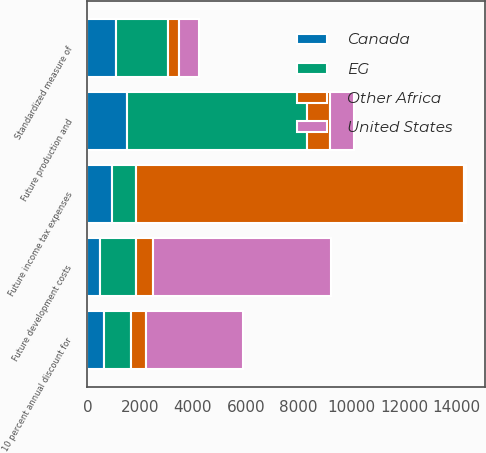Convert chart to OTSL. <chart><loc_0><loc_0><loc_500><loc_500><stacked_bar_chart><ecel><fcel>Future production and<fcel>Future development costs<fcel>Future income tax expenses<fcel>10 percent annual discount for<fcel>Standardized measure of<nl><fcel>EG<fcel>6796<fcel>1362<fcel>923<fcel>1041<fcel>1972<nl><fcel>United States<fcel>935<fcel>6715<fcel>60<fcel>3658<fcel>730<nl><fcel>Canada<fcel>1514<fcel>462<fcel>935<fcel>625<fcel>1084<nl><fcel>Other Africa<fcel>876<fcel>677<fcel>12419<fcel>571<fcel>431<nl></chart> 